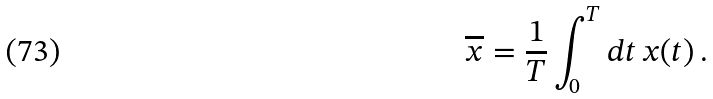<formula> <loc_0><loc_0><loc_500><loc_500>\overline { x } = \frac { 1 } { T } \int _ { 0 } ^ { T } d t \, x ( t ) \, .</formula> 